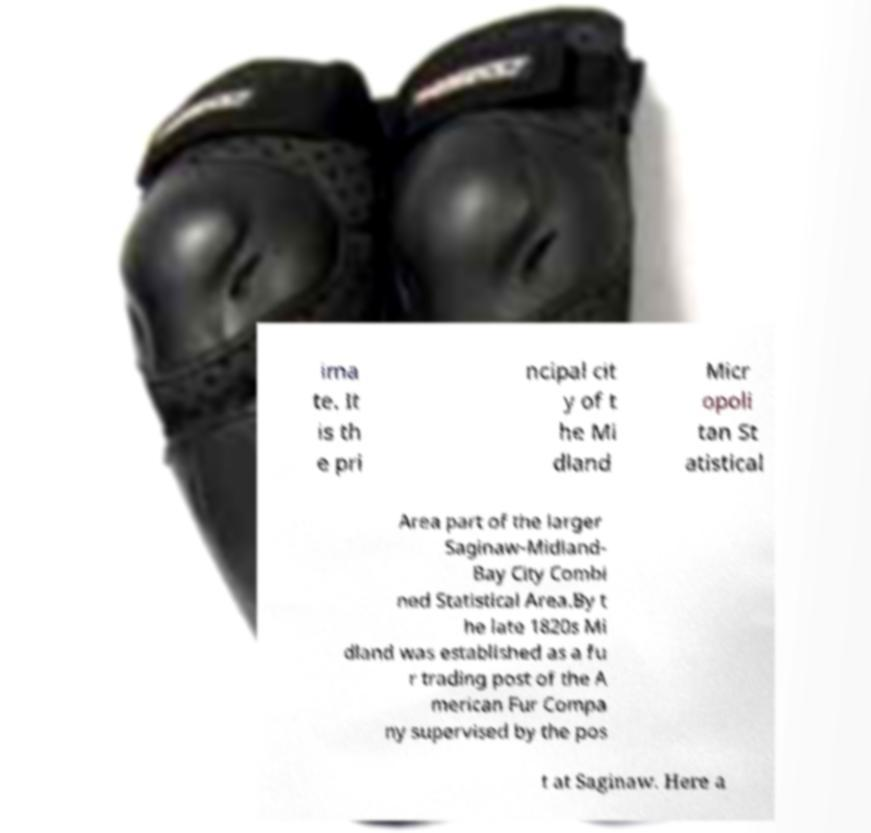Please identify and transcribe the text found in this image. ima te. It is th e pri ncipal cit y of t he Mi dland Micr opoli tan St atistical Area part of the larger Saginaw-Midland- Bay City Combi ned Statistical Area.By t he late 1820s Mi dland was established as a fu r trading post of the A merican Fur Compa ny supervised by the pos t at Saginaw. Here a 